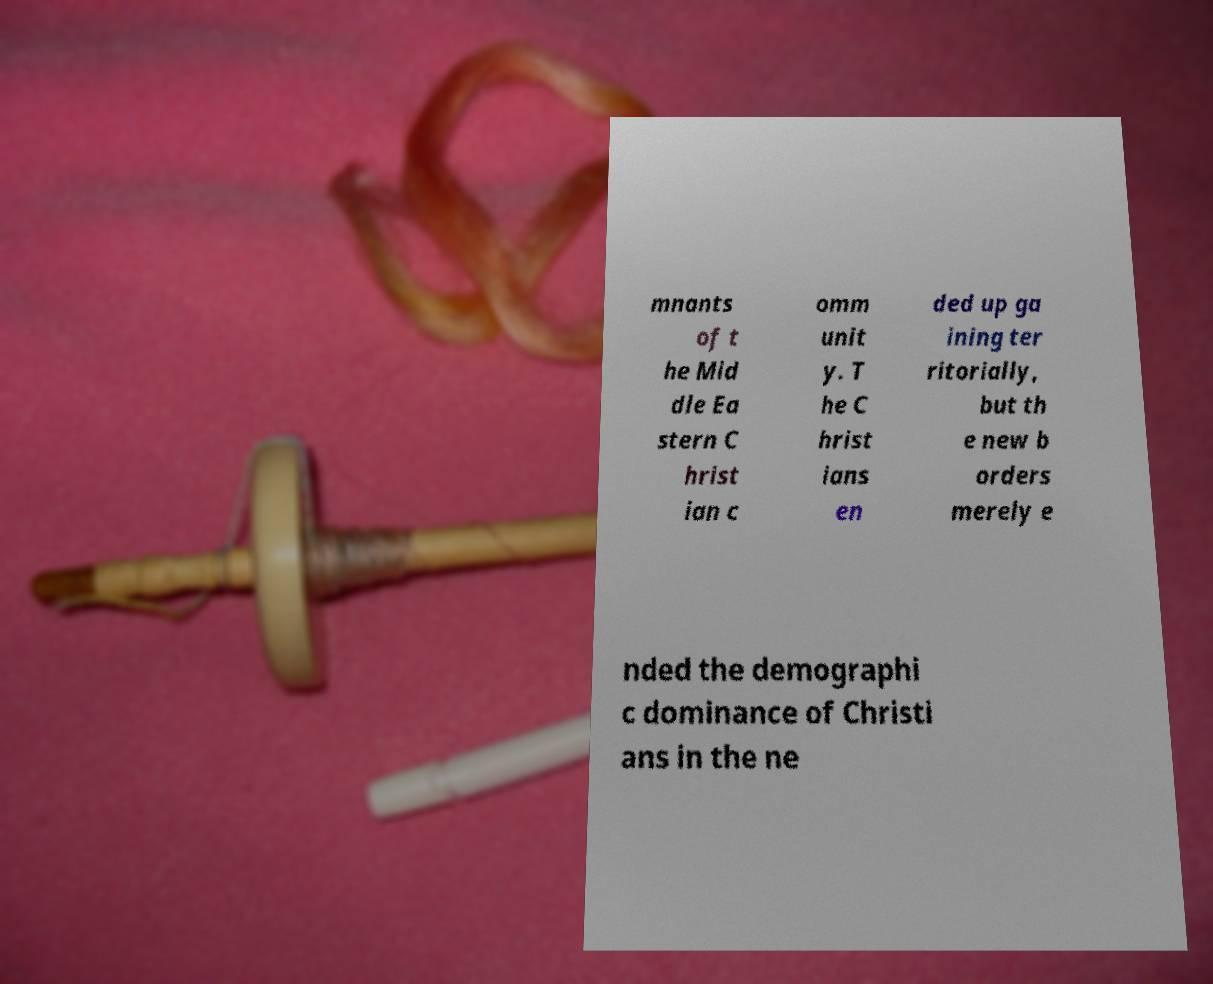There's text embedded in this image that I need extracted. Can you transcribe it verbatim? mnants of t he Mid dle Ea stern C hrist ian c omm unit y. T he C hrist ians en ded up ga ining ter ritorially, but th e new b orders merely e nded the demographi c dominance of Christi ans in the ne 